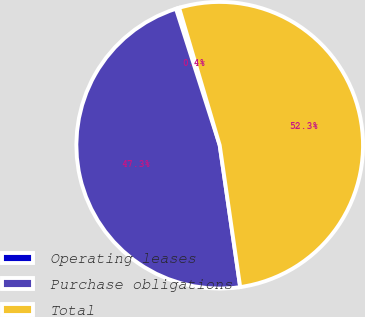Convert chart to OTSL. <chart><loc_0><loc_0><loc_500><loc_500><pie_chart><fcel>Operating leases<fcel>Purchase obligations<fcel>Total<nl><fcel>0.36%<fcel>47.35%<fcel>52.29%<nl></chart> 